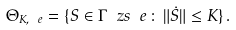Convert formula to latex. <formula><loc_0><loc_0><loc_500><loc_500>\Theta _ { K , \ e } = \{ S \in \Gamma _ { \ } z s { \ e } \, \colon \, \| \dot { S } \| \leq K \} \, .</formula> 